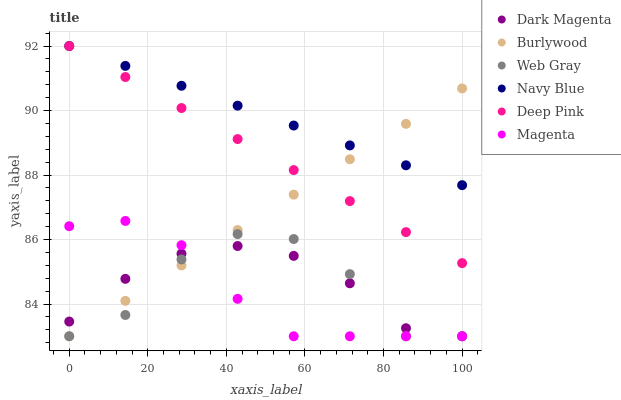Does Magenta have the minimum area under the curve?
Answer yes or no. Yes. Does Navy Blue have the maximum area under the curve?
Answer yes or no. Yes. Does Dark Magenta have the minimum area under the curve?
Answer yes or no. No. Does Dark Magenta have the maximum area under the curve?
Answer yes or no. No. Is Navy Blue the smoothest?
Answer yes or no. Yes. Is Web Gray the roughest?
Answer yes or no. Yes. Is Dark Magenta the smoothest?
Answer yes or no. No. Is Dark Magenta the roughest?
Answer yes or no. No. Does Web Gray have the lowest value?
Answer yes or no. Yes. Does Navy Blue have the lowest value?
Answer yes or no. No. Does Deep Pink have the highest value?
Answer yes or no. Yes. Does Burlywood have the highest value?
Answer yes or no. No. Is Web Gray less than Deep Pink?
Answer yes or no. Yes. Is Navy Blue greater than Dark Magenta?
Answer yes or no. Yes. Does Burlywood intersect Web Gray?
Answer yes or no. Yes. Is Burlywood less than Web Gray?
Answer yes or no. No. Is Burlywood greater than Web Gray?
Answer yes or no. No. Does Web Gray intersect Deep Pink?
Answer yes or no. No. 